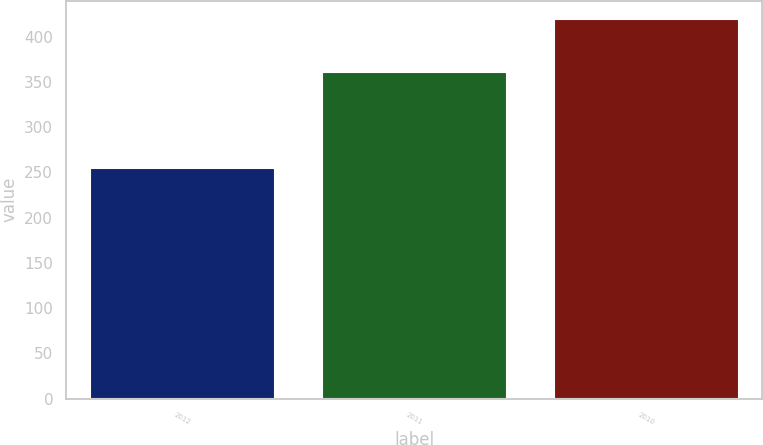<chart> <loc_0><loc_0><loc_500><loc_500><bar_chart><fcel>2012<fcel>2011<fcel>2010<nl><fcel>255<fcel>361<fcel>419<nl></chart> 